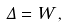Convert formula to latex. <formula><loc_0><loc_0><loc_500><loc_500>\Delta = W \, ,</formula> 